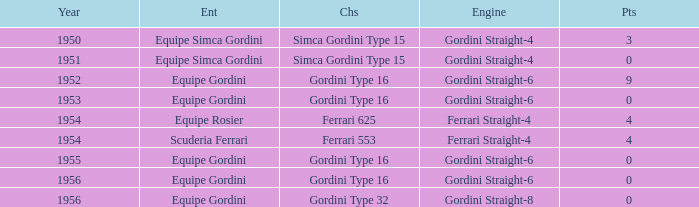What engine was used by Equipe Simca Gordini before 1956 with less than 4 points? Gordini Straight-4, Gordini Straight-4. 